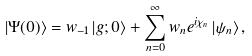Convert formula to latex. <formula><loc_0><loc_0><loc_500><loc_500>\left | \Psi ( 0 ) \right \rangle = w _ { - 1 } \left | g ; 0 \right \rangle + \sum _ { n = 0 } ^ { \infty } w _ { n } e ^ { i \chi _ { n } } \left | \psi _ { n } \right \rangle ,</formula> 